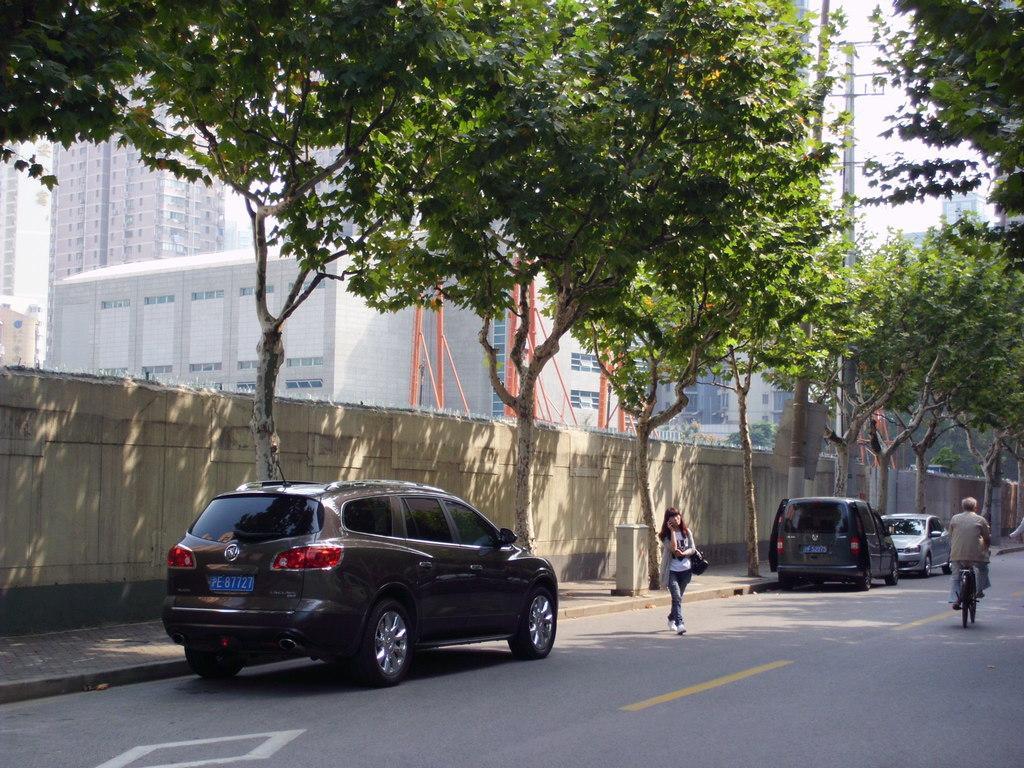Please provide a concise description of this image. In this picture we can see a woman crossing the road and a person on the bicycle. There are three cars on the road. This is the wall. These are the trees. And there is a pole. And on the background there are buildings and this is the sky. 